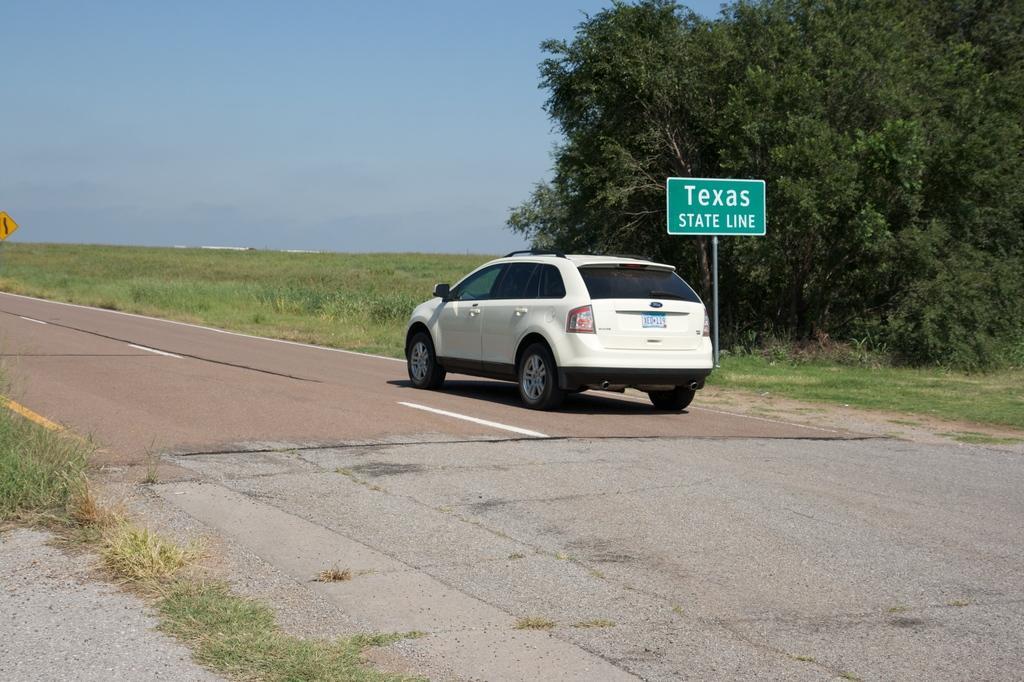How would you summarize this image in a sentence or two? In this image there is a white color car on the road. Beside the car there is a pole having a board attached to it. Right side there are few trees on the grassland. Left side there is a board. Left bottom there is some grass on the land. Top of the image there is sky. 